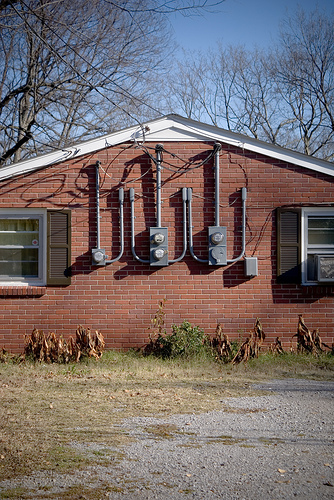<image>
Is there a window next to the window? Yes. The window is positioned adjacent to the window, located nearby in the same general area. Is there a meter in front of the roof? No. The meter is not in front of the roof. The spatial positioning shows a different relationship between these objects. 